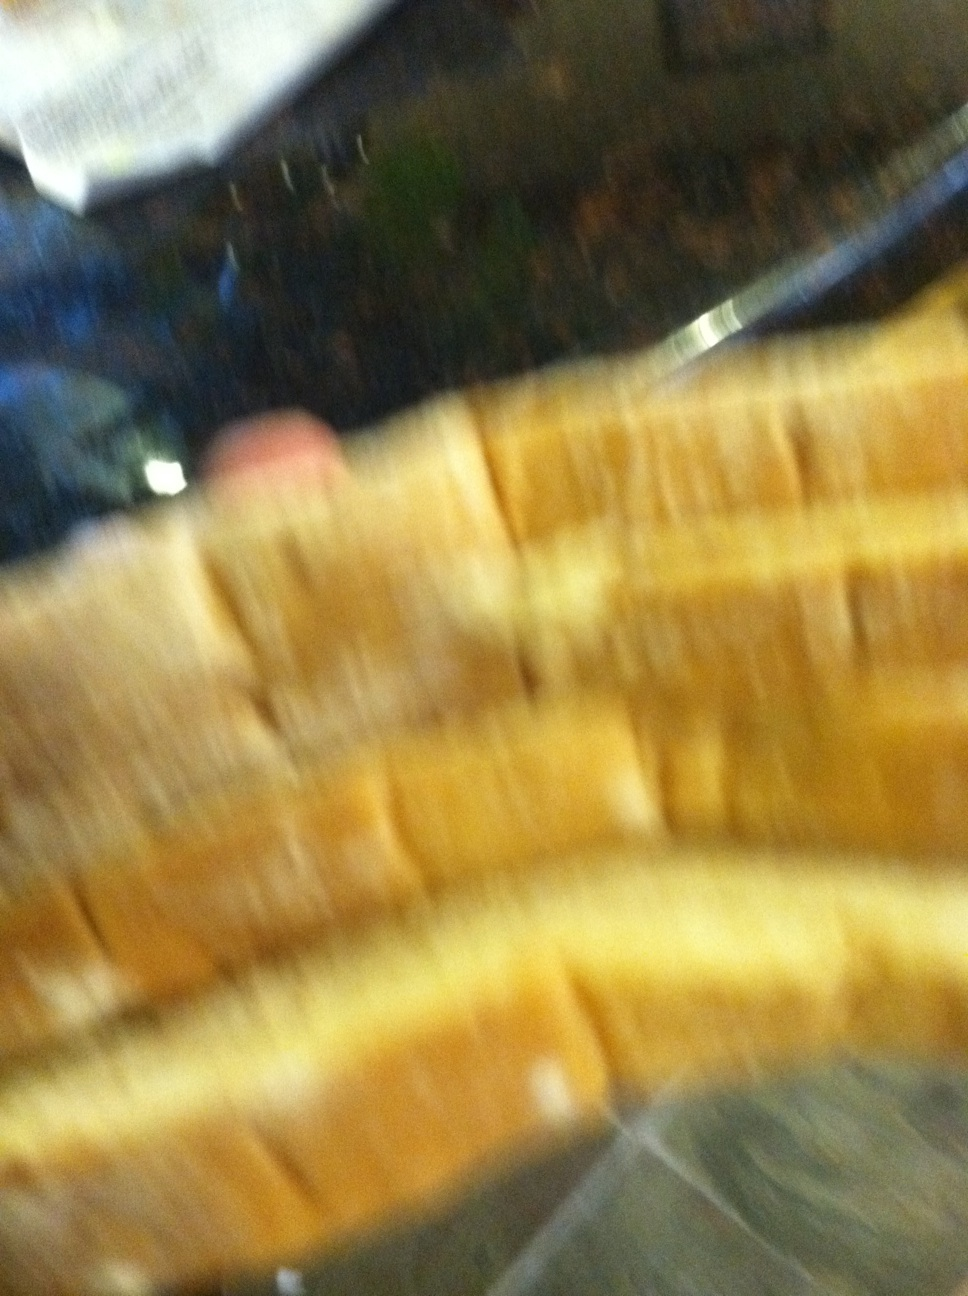Describe a scenario where this bread plays a crucial role. In a quaint village nestled in a valley, this loaf of bread becomes the center of an annual festival. Every year, villagers compete to make the most delicious and creatively decorated bread. This particular loaf, with its perfectly golden crust and soft interior, wins the top prize. The baker, a humble villager, becomes a hero for the day, and the bread is shared amongst the townspeople, symbolizing unity and prosperity. What's a quick meal you can make with this bread? A quick meal you can make with this bread would be a classic grilled cheese sandwich. Simply take two slices of this bread, place slices of your favorite cheese in between, butter the outside of the bread, and grill until the bread is golden brown and the cheese is melted. It's simple, quick, and delicious! What about a more elaborate recipe involving this bread? For a more elaborate recipe, you could use this bread to create a gourmet French toast casserole. Start by cutting the bread into cubes and placing them in a baking dish. In a separate bowl, whisk together eggs, milk, cream, sugar, vanilla extract, and a touch of cinnamon. Pour this mixture over the bread and let it soak overnight in the refrigerator. In the morning, top the casserole with a mixture of brown sugar, flour, and butter, then bake it until it’s puffed and golden. Serve it with a drizzle of maple syrup and fresh berries for a decadent breakfast or brunch dish. If this bread were part of a fairytale, what would its story be? In the heart of an enchanted forest, there once was a loaf of bread with magical properties. Baked by the kind-hearted village baker, this bread had the ability to make anyone who ate it feel an overwhelming sense of happiness and contentment. One day, the village fell under a dark spell that made everyone feel sad and hopeless. Hearing of their plight, the baker ventured into the forest with his enchanted bread. As the villagers took their first bites, their smiles returned, and the darkness lifted. The bread became legendary, and the baker was celebrated as a hero who brought joy and unity to the village once more. 